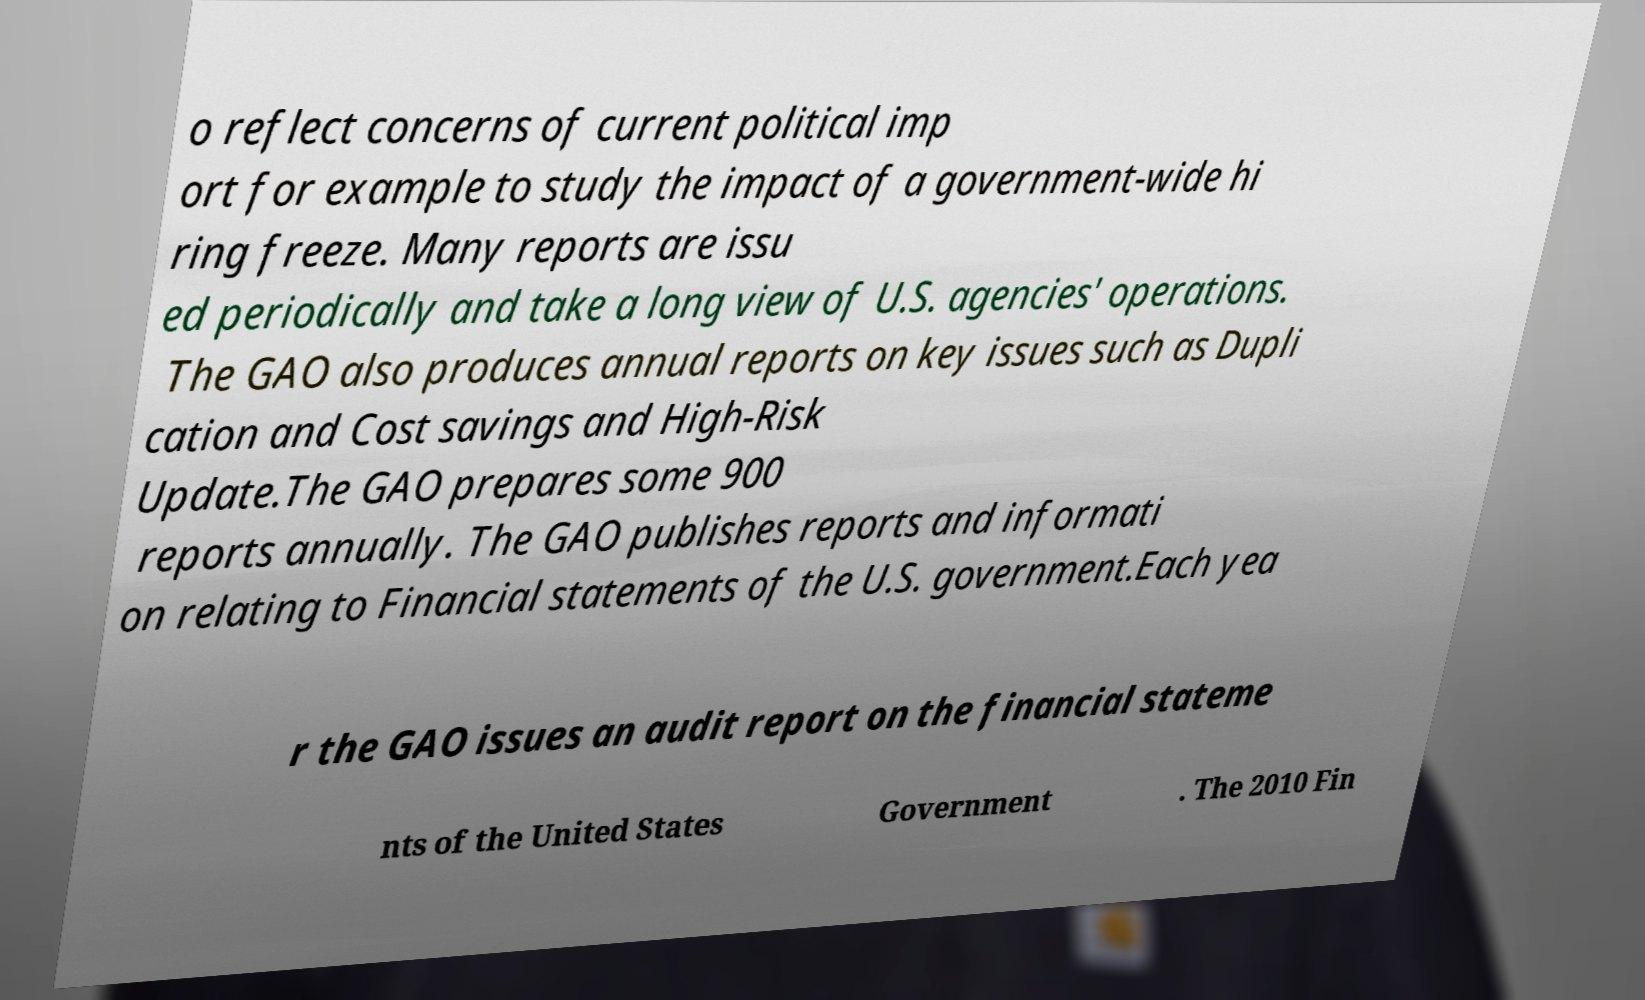What messages or text are displayed in this image? I need them in a readable, typed format. o reflect concerns of current political imp ort for example to study the impact of a government-wide hi ring freeze. Many reports are issu ed periodically and take a long view of U.S. agencies' operations. The GAO also produces annual reports on key issues such as Dupli cation and Cost savings and High-Risk Update.The GAO prepares some 900 reports annually. The GAO publishes reports and informati on relating to Financial statements of the U.S. government.Each yea r the GAO issues an audit report on the financial stateme nts of the United States Government . The 2010 Fin 